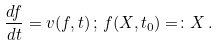Convert formula to latex. <formula><loc_0><loc_0><loc_500><loc_500>\frac { d { f } } { d t } = { v } ( { f } , t ) \, ; \, { f } ( { X } , t _ { 0 } ) = \colon { X } \, .</formula> 